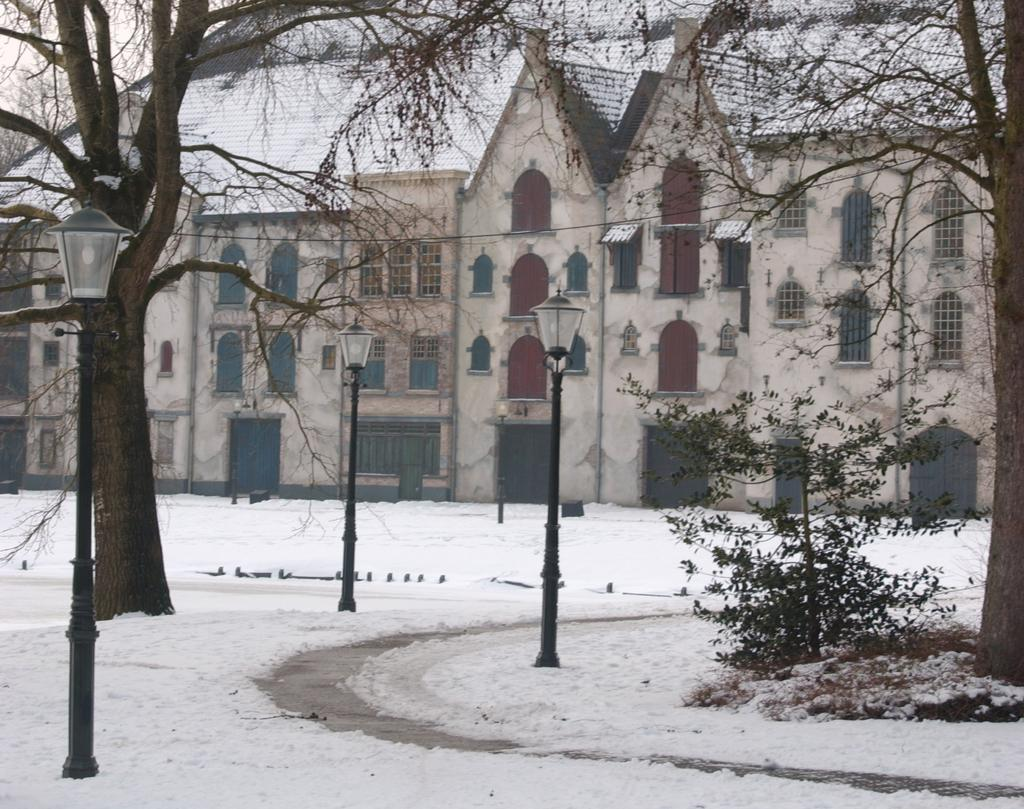What type of structures can be seen in the image? There are multiple buildings in the image. What other natural elements are present in the image? There are trees and a plant visible in the image. How many light poles are in the image? There are 3 light poles in the image. What is the condition of the path in the image? There is snow on the path in the image. What type of scarf is being used to decorate the iron skate in the image? There is no scarf, iron, or skate present in the image. 